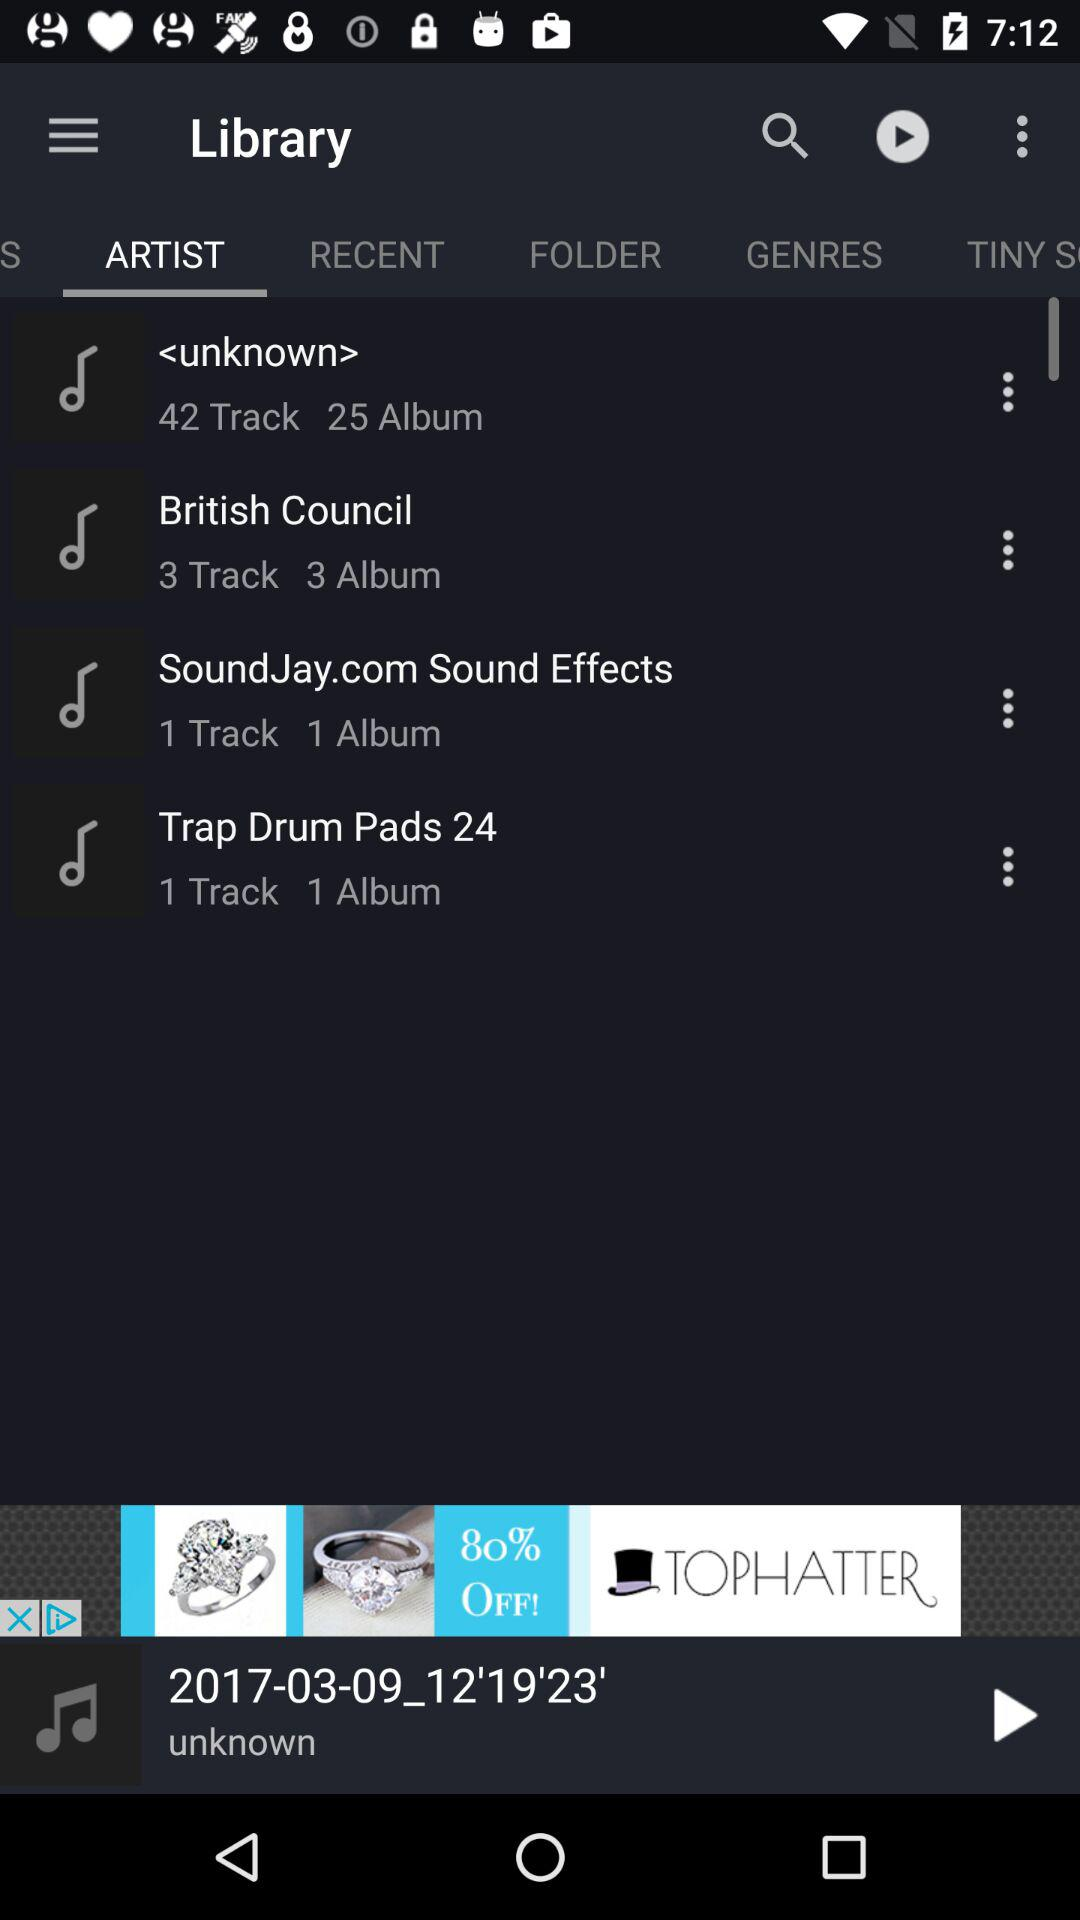Which tab is selected? The selected tab is "ARTIST". 